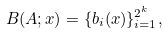Convert formula to latex. <formula><loc_0><loc_0><loc_500><loc_500>B ( A ; x ) = \{ b _ { i } ( x ) \} _ { i = 1 } ^ { 2 ^ { k } } ,</formula> 